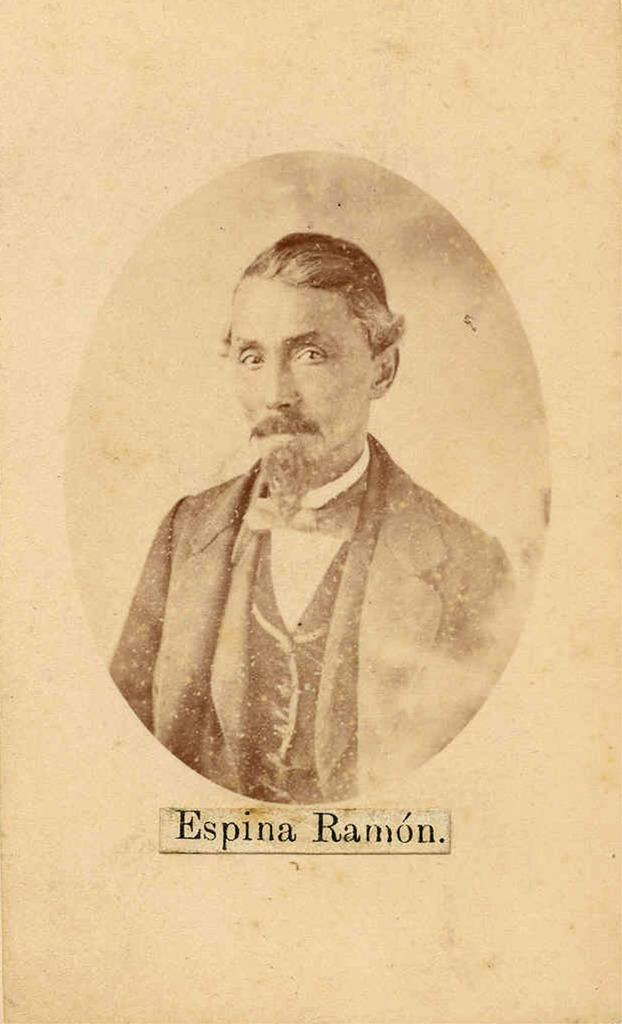What is the color scheme of the image? The image is black and white. What is the main subject of the image? There is a person in the center of the image. Is there any text present in the image? Yes, there is some text at the bottom of the image. Can you describe the amusement park in the background of the image? There is no amusement park present in the image; it is black and white with a person in the center and some text at the bottom. 